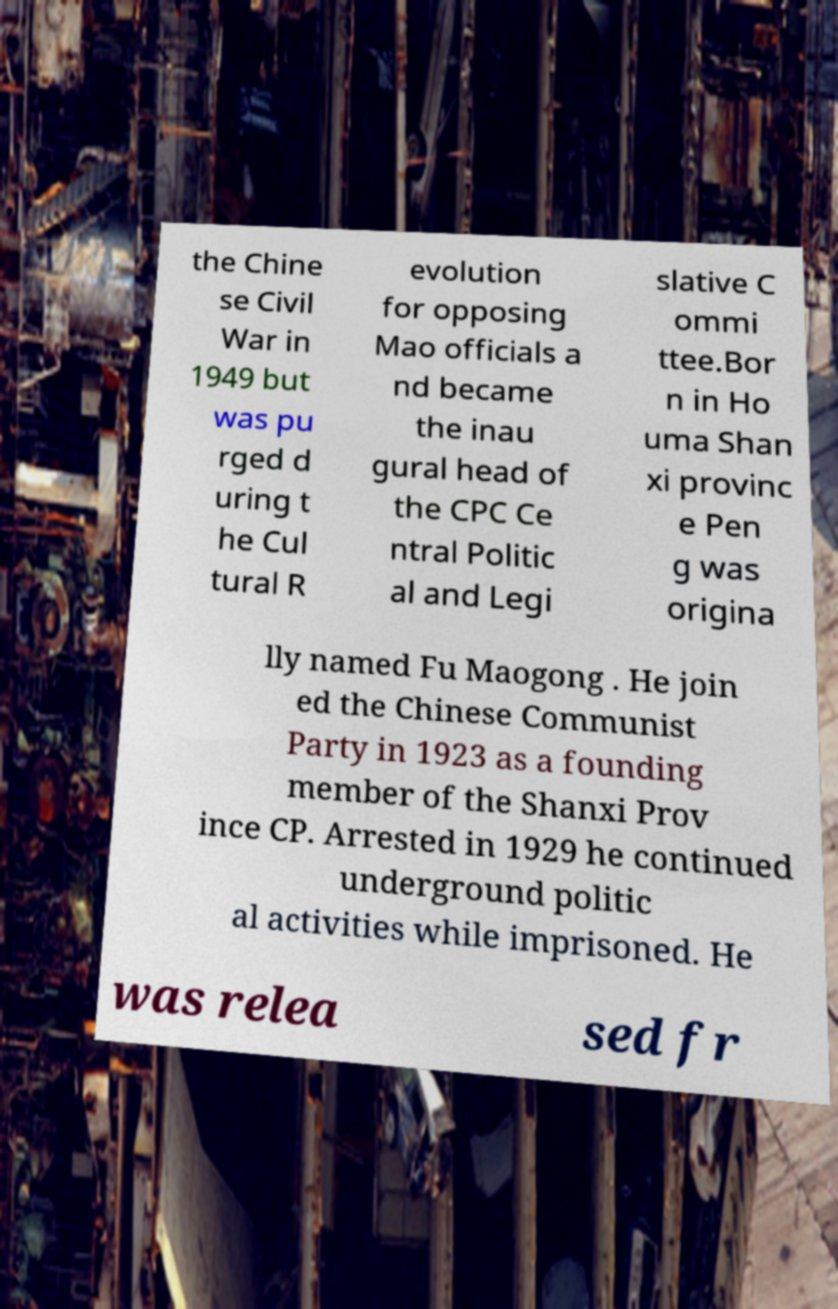Please identify and transcribe the text found in this image. the Chine se Civil War in 1949 but was pu rged d uring t he Cul tural R evolution for opposing Mao officials a nd became the inau gural head of the CPC Ce ntral Politic al and Legi slative C ommi ttee.Bor n in Ho uma Shan xi provinc e Pen g was origina lly named Fu Maogong . He join ed the Chinese Communist Party in 1923 as a founding member of the Shanxi Prov ince CP. Arrested in 1929 he continued underground politic al activities while imprisoned. He was relea sed fr 